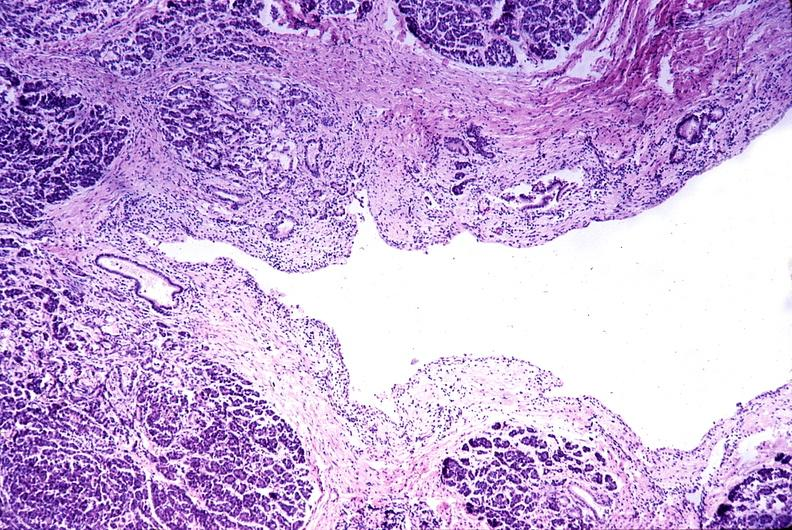where is this?
Answer the question using a single word or phrase. Pancreas 